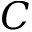<formula> <loc_0><loc_0><loc_500><loc_500>C</formula> 